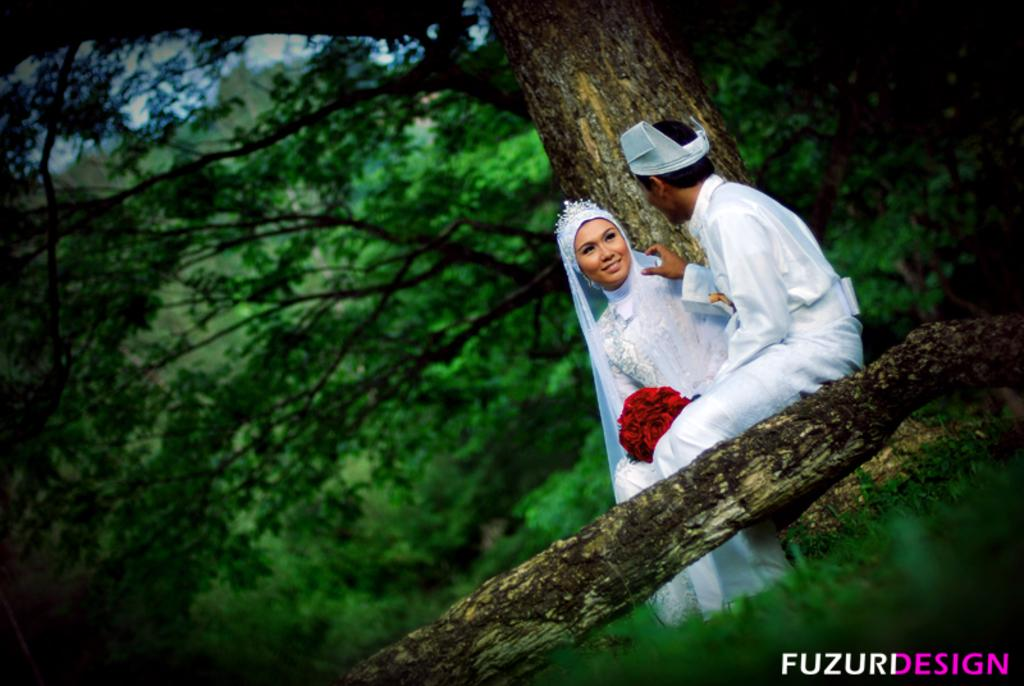How many people are in the image? There are two people in the image, a man and a woman. What are the man and woman holding in the image? They are holding a flower bouquet. Where are the man and woman sitting in the image? They are sitting on the branch of a tree. What can be seen in the background of the image? There are trees visible in the background of the image. What is present at the bottom of the image? There is some text at the bottom of the image. How does the stranger react to the earthquake in the image? There is no stranger or earthquake present in the image. What type of doll is sitting on the branch with the man and woman in the image? There is no doll present in the image; it features a man and a woman sitting on the branch. 